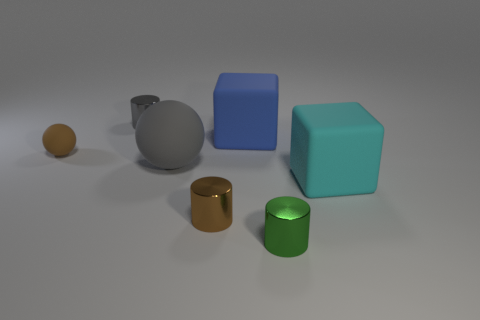There is another thing that is the same shape as the tiny brown rubber object; what material is it?
Give a very brief answer. Rubber. Do the tiny green shiny thing and the big gray matte thing have the same shape?
Provide a short and direct response. No. What number of large blue objects are left of the blue matte block?
Ensure brevity in your answer.  0. The small shiny object behind the cube that is on the right side of the large blue matte object is what shape?
Give a very brief answer. Cylinder. What is the shape of the large cyan object that is made of the same material as the tiny sphere?
Ensure brevity in your answer.  Cube. Does the rubber cube to the right of the big blue thing have the same size as the ball behind the big sphere?
Offer a terse response. No. The tiny metal thing that is to the left of the brown metallic thing has what shape?
Your response must be concise. Cylinder. What color is the large ball?
Make the answer very short. Gray. Does the gray matte thing have the same size as the cylinder behind the tiny rubber thing?
Make the answer very short. No. How many metallic things are tiny gray cubes or big gray spheres?
Provide a succinct answer. 0. 